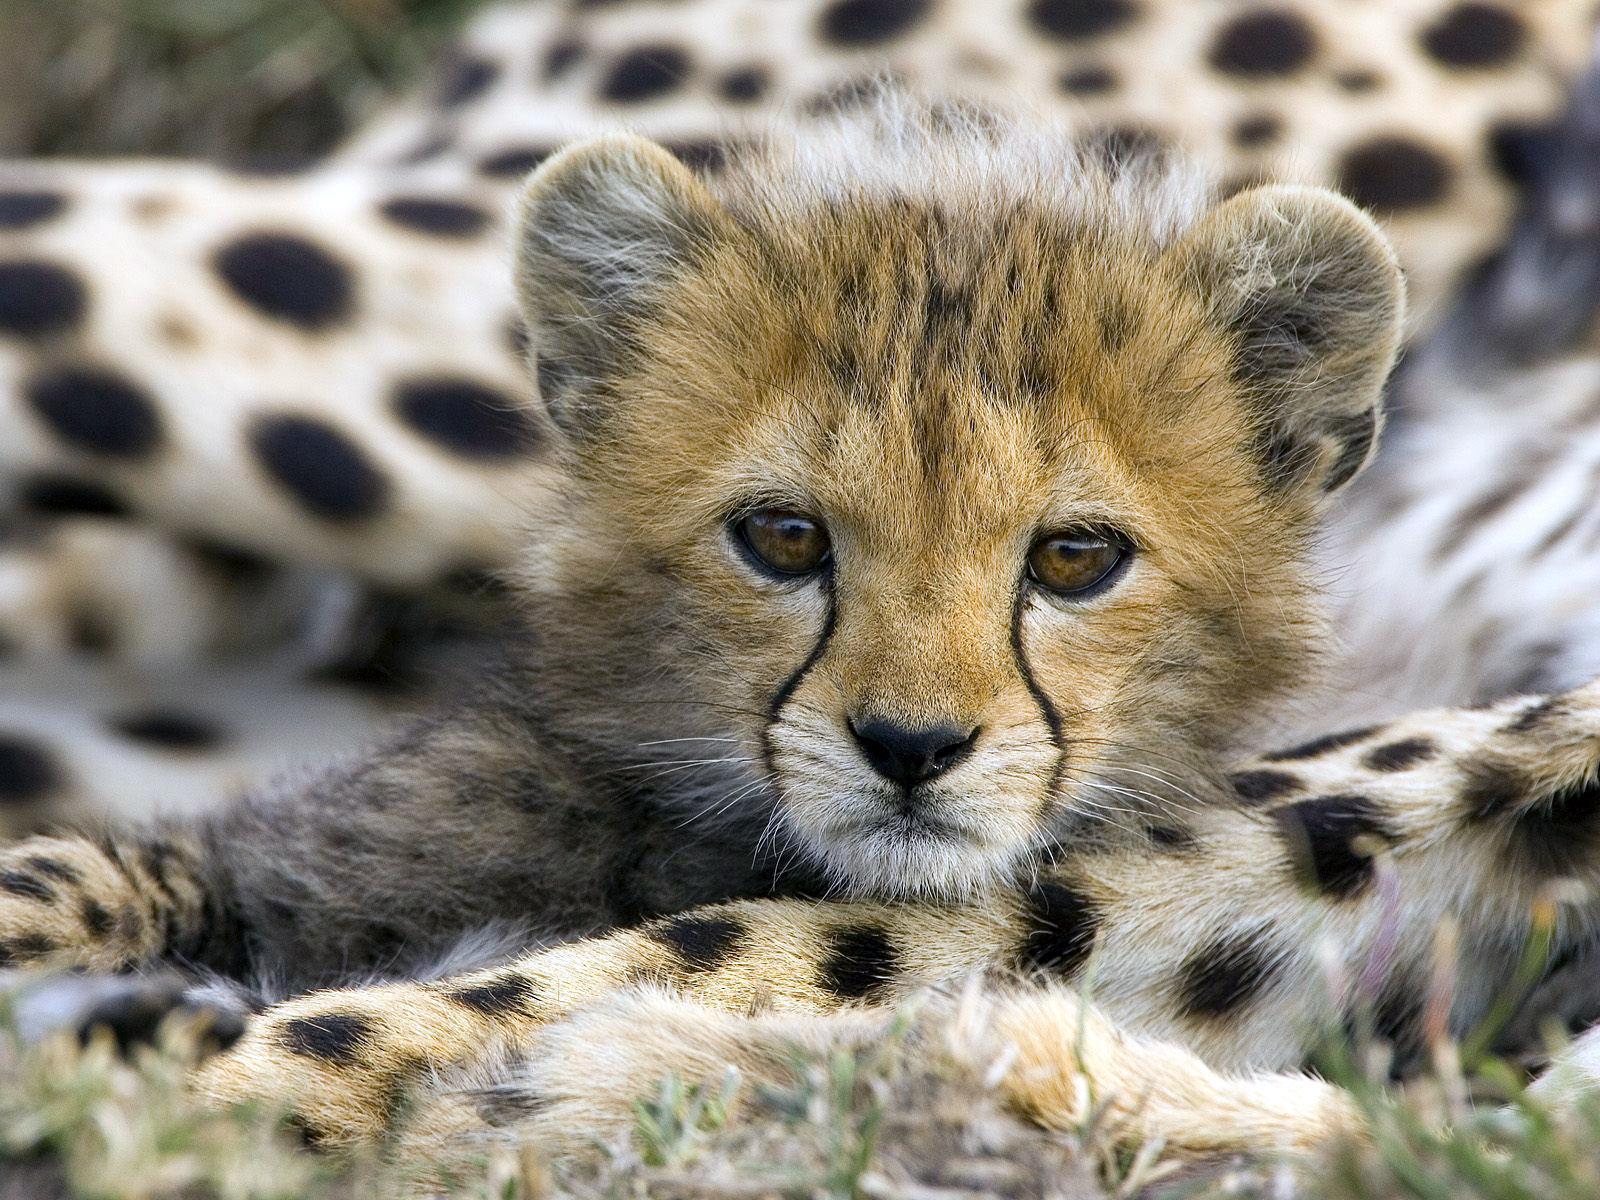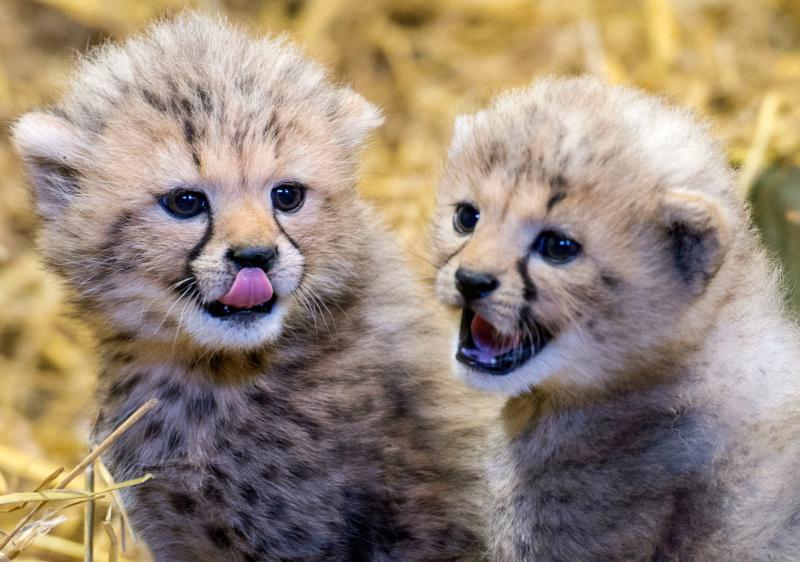The first image is the image on the left, the second image is the image on the right. Evaluate the accuracy of this statement regarding the images: "One image shows at least two cheetah kittens to the left of an adult cheetah's face.". Is it true? Answer yes or no. No. The first image is the image on the left, the second image is the image on the right. Examine the images to the left and right. Is the description "The right image contains exactly two baby cheetahs." accurate? Answer yes or no. Yes. 